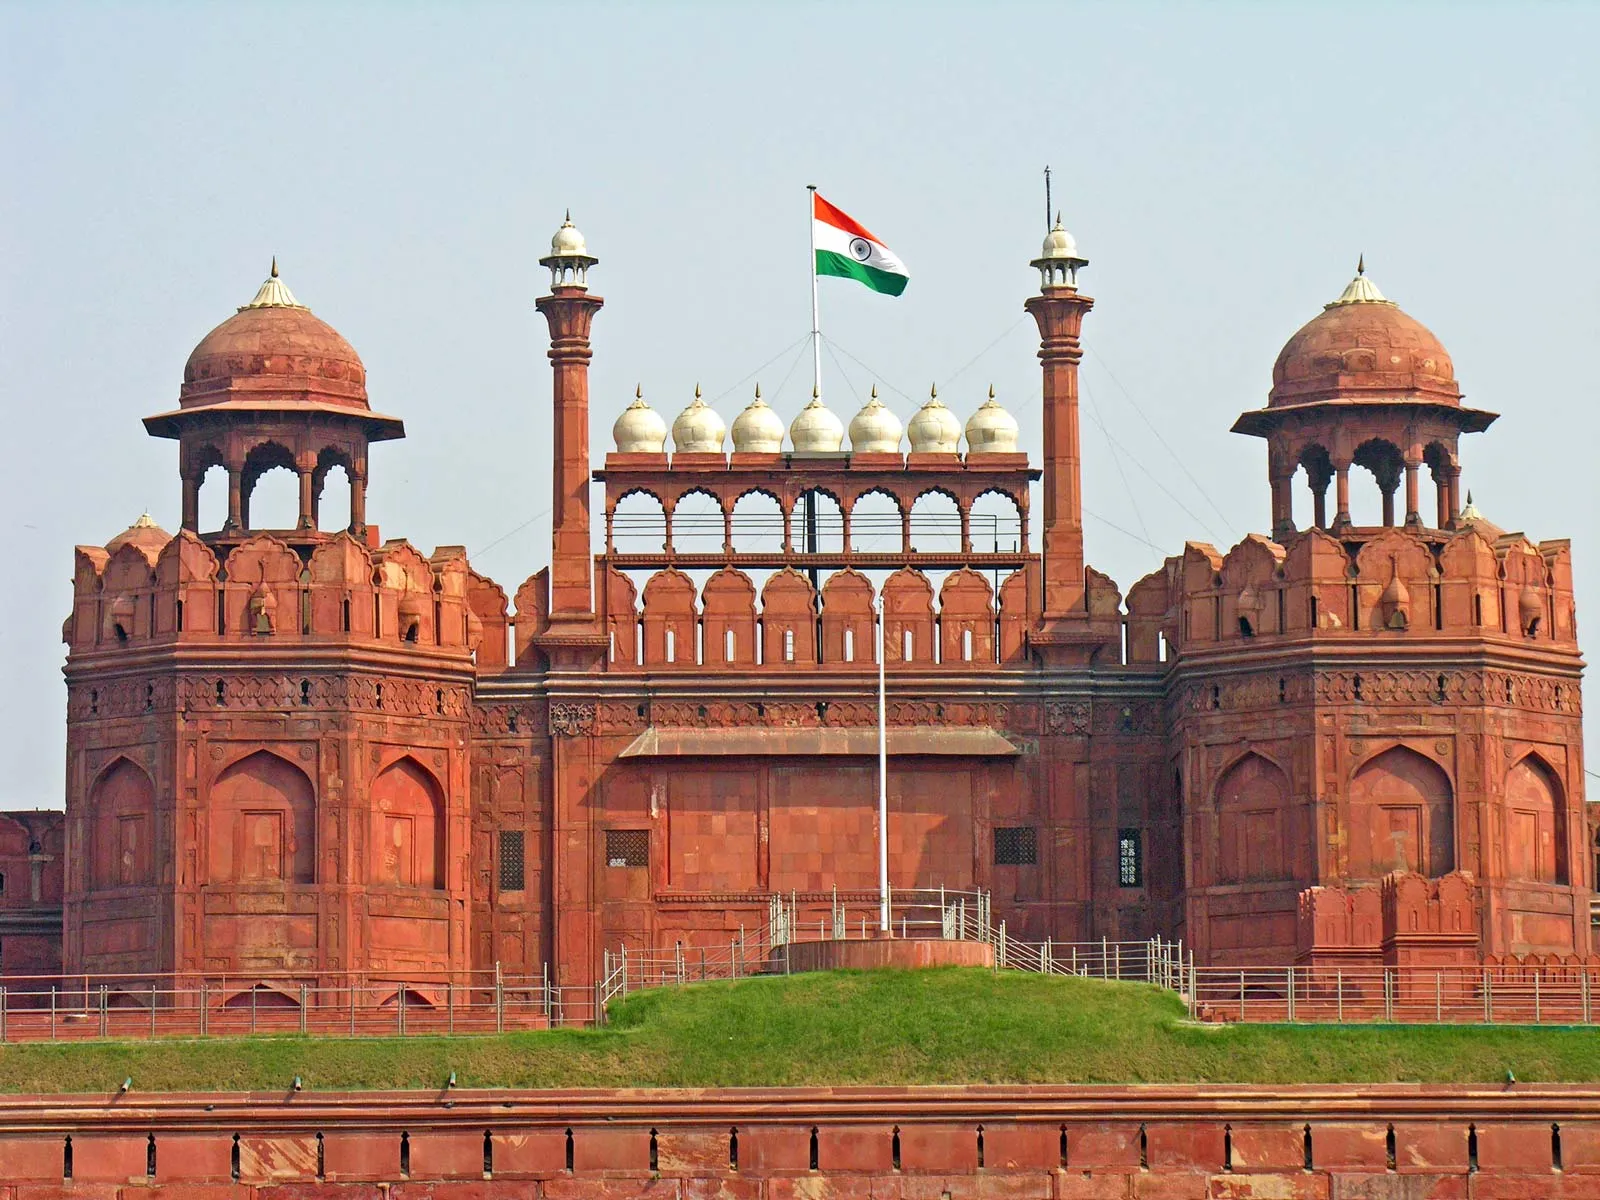What is this photo about'? The image showcases the majestic Red Fort Complex located in India, a symbol of the country's rich heritage and history. This UNESCO World Heritage Site, constructed from red sandstone, stands out with its magnificent architectural design. The central structure features an impressive white dome, flanked by two large domed towers, which creates a beautifully symmetrical layout. A series of smaller domes line the roof of the central building, adding to the fort's intricate and elegant design. The Indian flag proudly waves atop a flagpole, symbolizing the nation's pride and independence. Surrounding the fort is a defensive moat, enhancing the sense of security and grandeur. The foreground's lush greenery contrasts vividly with the imposing red sandstone structures, blending nature with human achievement. This picture effectively highlights the historical and architectural significance of the Red Fort Complex. 